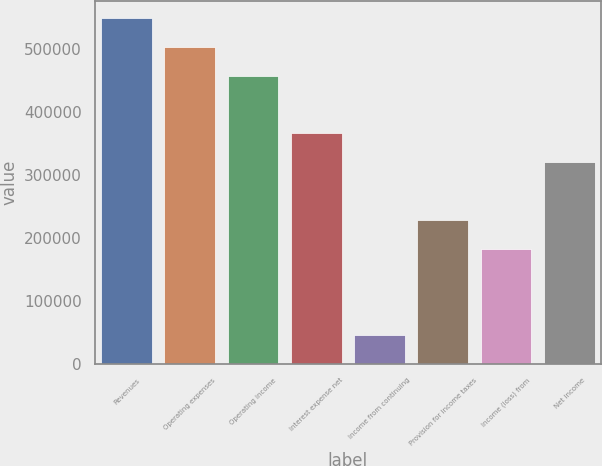<chart> <loc_0><loc_0><loc_500><loc_500><bar_chart><fcel>Revenues<fcel>Operating expenses<fcel>Operating income<fcel>Interest expense net<fcel>Income from continuing<fcel>Provision for income taxes<fcel>Income (loss) from<fcel>Net income<nl><fcel>549047<fcel>503293<fcel>457539<fcel>366031<fcel>45754.3<fcel>228770<fcel>183016<fcel>320277<nl></chart> 